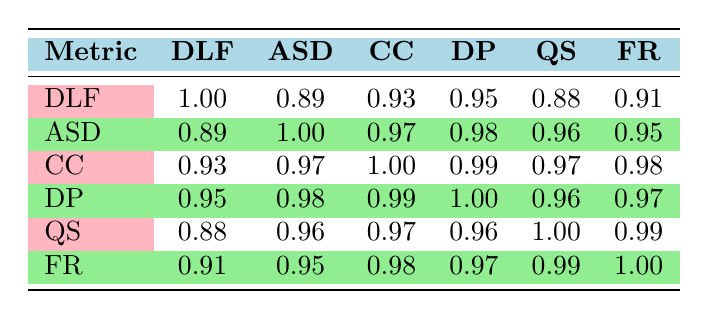What is the correlation between Daily Login Frequency and Courses Completed? The correlation coefficient between Daily Login Frequency (DLF) and Courses Completed (CC) is 0.93, indicating a strong positive relationship.
Answer: 0.93 What is the highest average session duration recorded? By looking at the Average Session Duration (ASD) column, the highest value is 45 minutes, attributed to UserID 103.
Answer: 45 Is there a correlation of 1.0 between any two metrics? No, all correlation coefficients are less than 1.00, indicating that no two metrics have a perfect positive correlation.
Answer: No How does the average Quiz Scores of users with different Daily Login Frequencies compare? To find the average Quiz Scores (QS) for users with different DLF, sum the scores (85 + 78 + 92 + 70 + 88) to get 413, then divide by the number of users (5): 413/5 = 82.6.
Answer: 82.6 Which metric shows the highest correlation with Discussion Posts? Discussion Posts (DP) has the highest correlation with Courses Completed (CC) at 0.99, indicating a very strong relationship.
Answer: 0.99 What is the overall trend regarding Feedback Ratings in relation to Daily Login Frequency? As Daily Login Frequency increases, the Feedback Ratings (FR) also tend to be higher, suggesting users who log in more frequently tend to provide better feedback.
Answer: Positive trend What are the average scores across all users for Feedback Ratings? Calculate the average of the Feedback Ratings (4.8 + 4.5 + 4.9 + 4.2 + 4.7) which equals 24.1. Divide that by the number of users (5) to get an average of 4.82.
Answer: 4.82 Has there been a user that scored below 70 in Quiz Scores? Yes, UserID 104 has a Quiz Score of 70, which is below the average of other users.
Answer: Yes What is the range of Daily Login Frequency across all users? The range is determined by subtracting the minimum DLF (2 for UserID 104) from the maximum DLF (7 for UserID 103): 7 - 2 = 5.
Answer: 5 